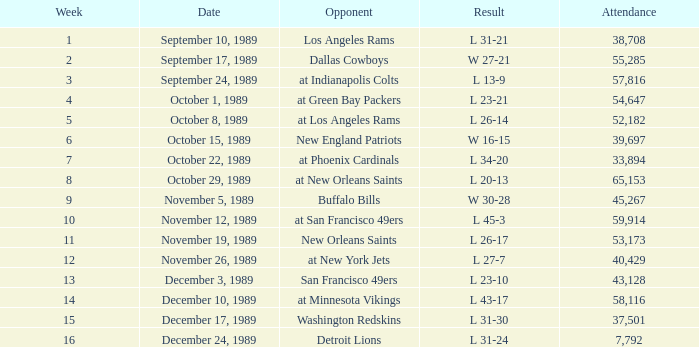On September 10, 1989 how many people attended the game? 38708.0. 